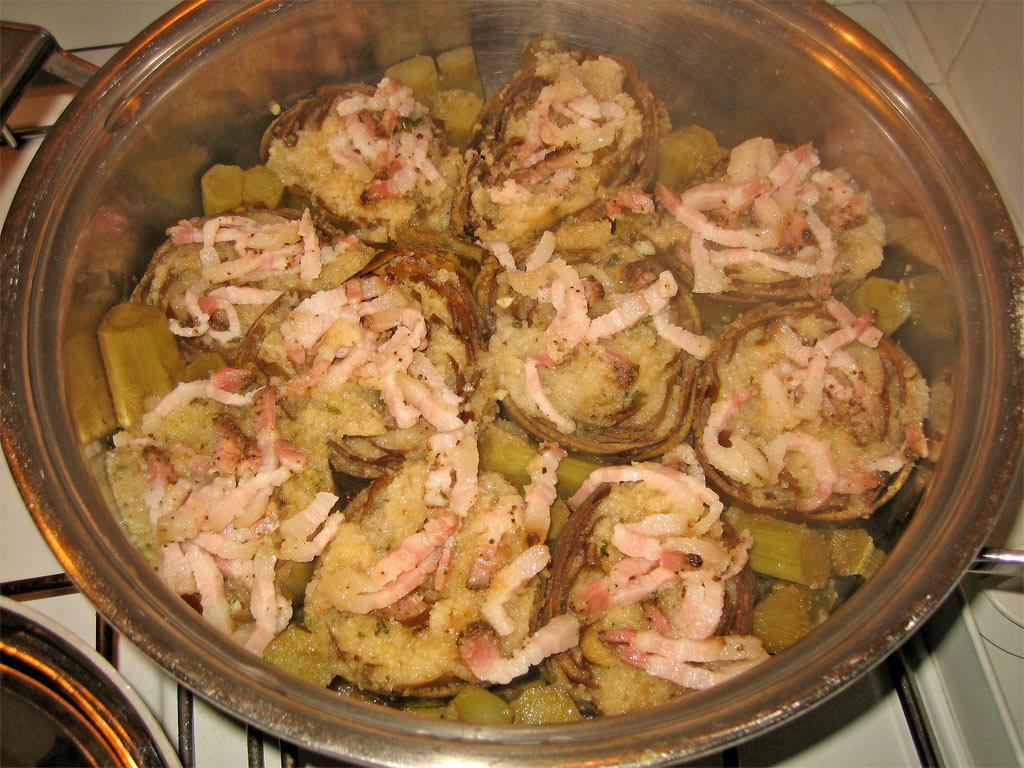What is in the bowl that is visible in the image? There is a bowl with food items in the image. What else can be seen in the image besides the bowl? There are other objects present in the image. Where are the bowl and the objects placed in the image? The bowl and the objects are placed on a stove. How many legs does the stove have in the image? The image does not show the legs of the stove, so it cannot be determined from the image. 